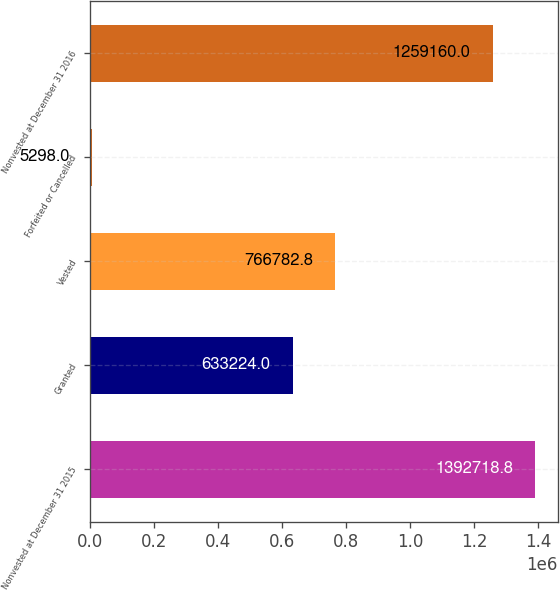Convert chart to OTSL. <chart><loc_0><loc_0><loc_500><loc_500><bar_chart><fcel>Nonvested at December 31 2015<fcel>Granted<fcel>Vested<fcel>Forfeited or Cancelled<fcel>Nonvested at December 31 2016<nl><fcel>1.39272e+06<fcel>633224<fcel>766783<fcel>5298<fcel>1.25916e+06<nl></chart> 